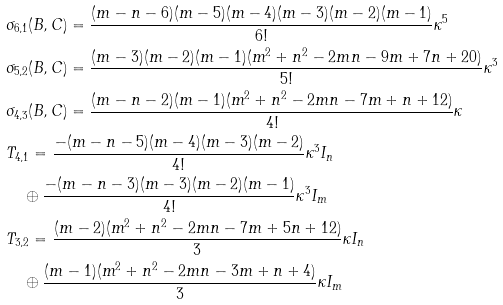<formula> <loc_0><loc_0><loc_500><loc_500>& \sigma _ { 6 , 1 } ( B , C ) = \frac { ( m - n - 6 ) ( m - 5 ) ( m - 4 ) ( m - 3 ) ( m - 2 ) ( m - 1 ) } { 6 ! } \kappa ^ { 5 } \\ & \sigma _ { 5 , 2 } ( B , C ) = \frac { ( m - 3 ) ( m - 2 ) ( m - 1 ) ( m ^ { 2 } + n ^ { 2 } - 2 m n - 9 m + 7 n + 2 0 ) } { 5 ! } \kappa ^ { 3 } \\ & \sigma _ { 4 , 3 } ( B , C ) = \frac { ( m - n - 2 ) ( m - 1 ) ( m ^ { 2 } + n ^ { 2 } - 2 m n - 7 m + n + 1 2 ) } { 4 ! } \kappa \\ & T _ { 4 , 1 } = \frac { - ( m - n - 5 ) ( m - 4 ) ( m - 3 ) ( m - 2 ) } { 4 ! } \kappa ^ { 3 } I _ { n } \\ & \quad \oplus \frac { - ( m - n - 3 ) ( m - 3 ) ( m - 2 ) ( m - 1 ) } { 4 ! } \kappa ^ { 3 } I _ { m } \\ & T _ { 3 , 2 } = \frac { ( m - 2 ) ( m ^ { 2 } + n ^ { 2 } - 2 m n - 7 m + 5 n + 1 2 ) } { 3 } \kappa I _ { n } \\ & \quad \oplus \frac { ( m - 1 ) ( m ^ { 2 } + n ^ { 2 } - 2 m n - 3 m + n + 4 ) } { 3 } \kappa I _ { m }</formula> 